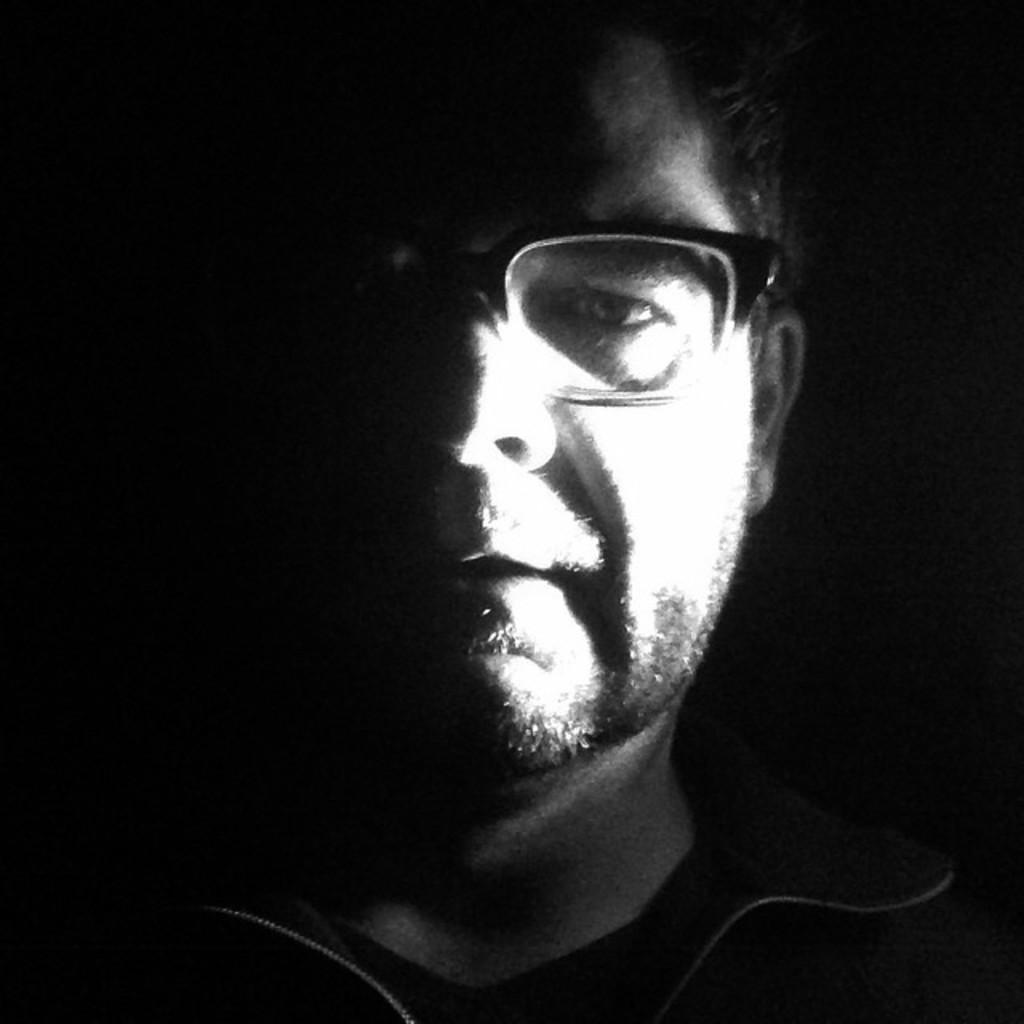What is the main subject of the picture? The main subject of the picture is a man. What can be observed about the man's appearance? The man is wearing spectacles. How is the image presented in terms of color? The image is in black and white color. What type of canvas is the man painting on in the image? There is no canvas or painting activity present in the image. How does the man plan to pay off his debt in the image? There is no mention of debt or any financial context in the image. 